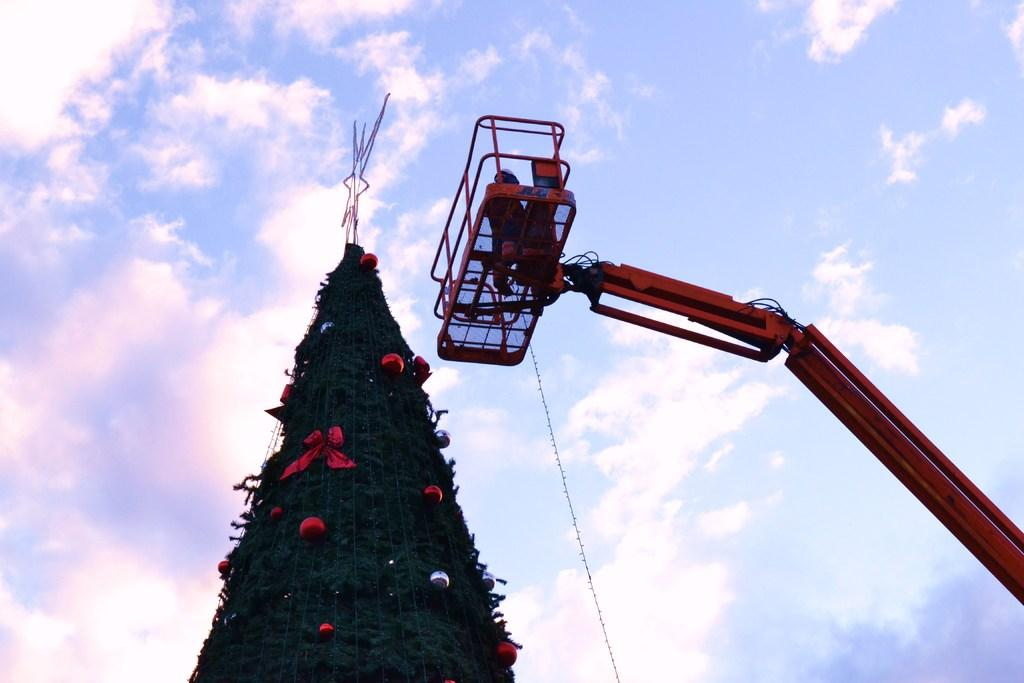What can be seen in the sky at the top of the image? The sky with clouds is visible at the top of the image. What is the main object in the image? There is a Christmas tree in the image. How is the Christmas tree decorated? The Christmas tree is decorated. What other object can be seen in the image? There is a crane in the image. What type of wood is the hydrant made of in the image? There is no hydrant present in the image. What disease is the crane suffering from in the image? There is no indication of any disease in the image, and the crane is not a living creature. 